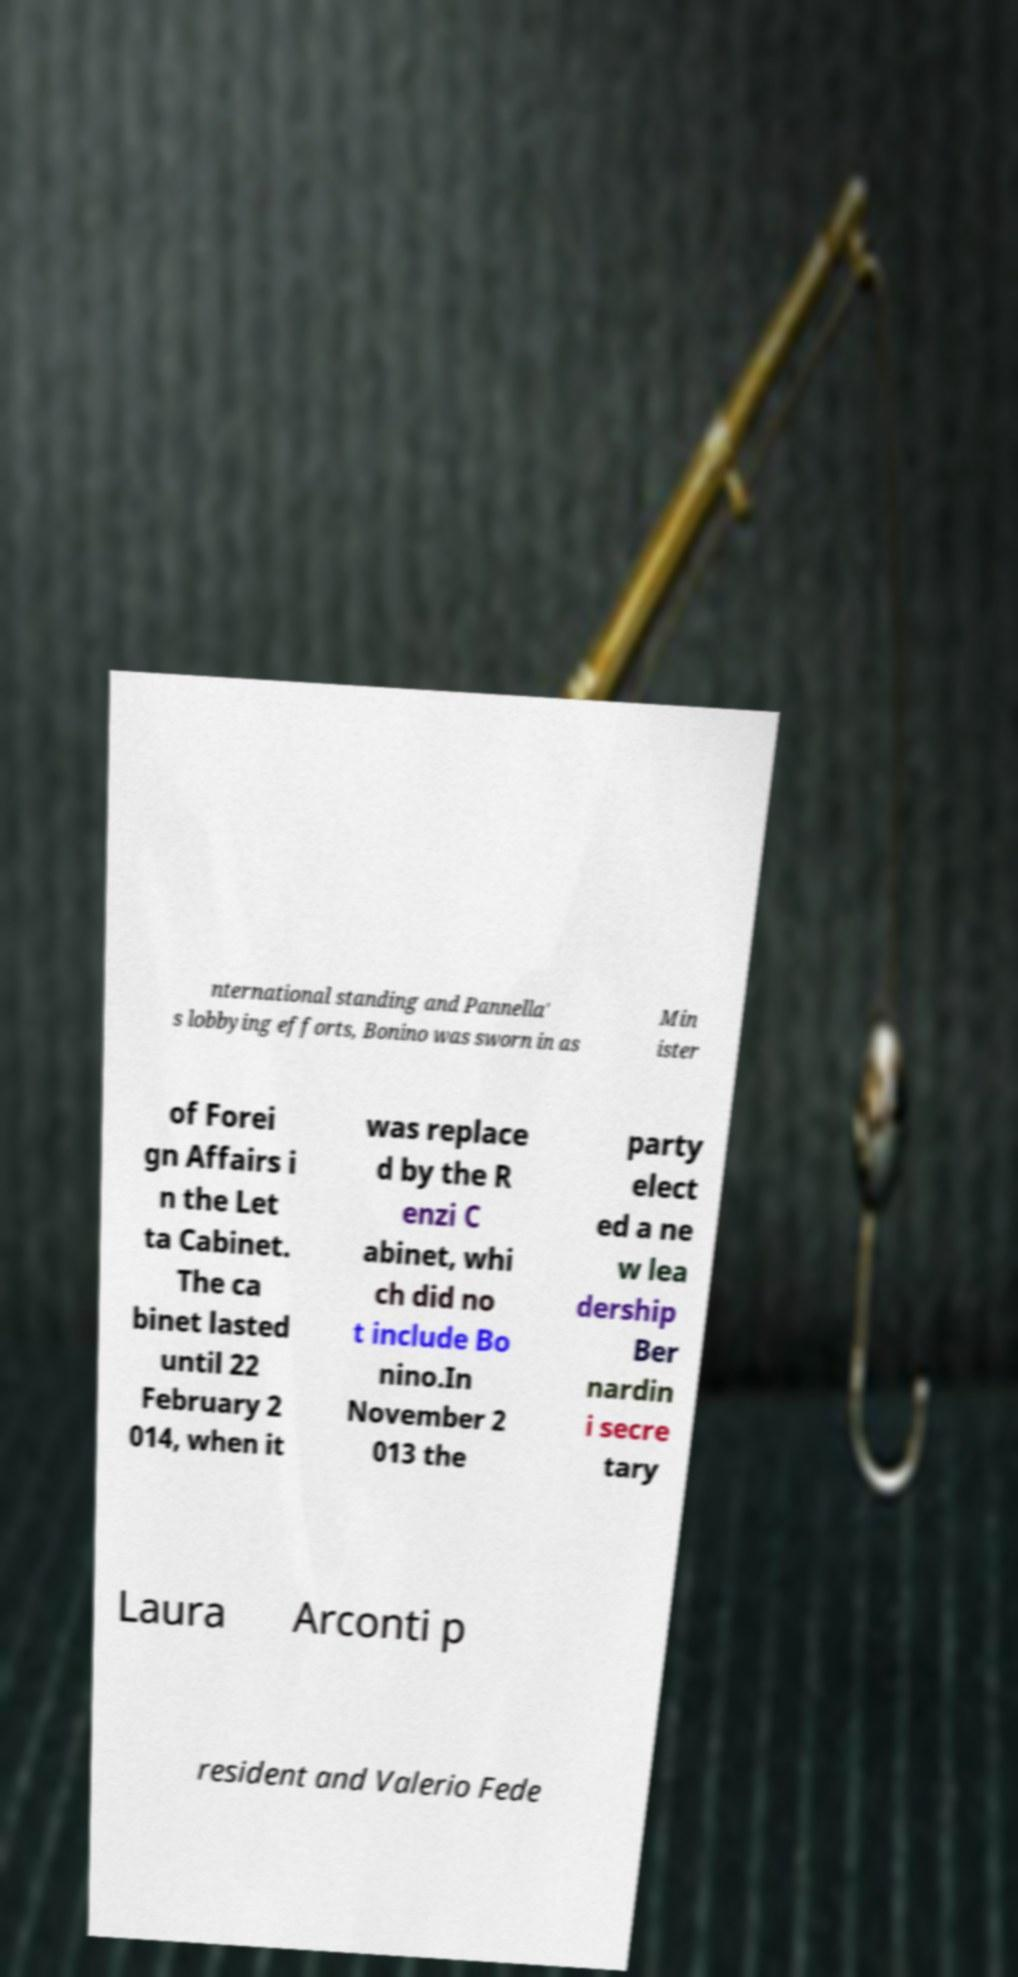Could you assist in decoding the text presented in this image and type it out clearly? nternational standing and Pannella' s lobbying efforts, Bonino was sworn in as Min ister of Forei gn Affairs i n the Let ta Cabinet. The ca binet lasted until 22 February 2 014, when it was replace d by the R enzi C abinet, whi ch did no t include Bo nino.In November 2 013 the party elect ed a ne w lea dership Ber nardin i secre tary Laura Arconti p resident and Valerio Fede 